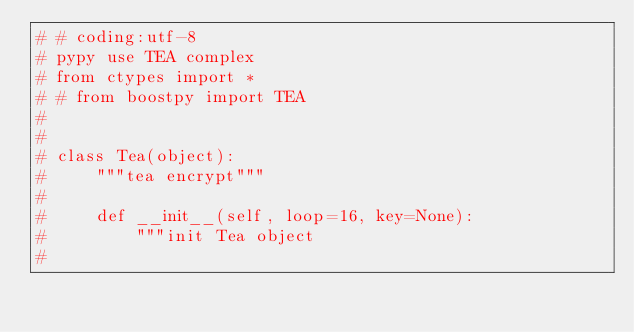<code> <loc_0><loc_0><loc_500><loc_500><_Python_># # coding:utf-8
# pypy use TEA complex
# from ctypes import *
# # from boostpy import TEA
#
#
# class Tea(object):
#     """tea encrypt"""
#
#     def __init__(self, loop=16, key=None):
#         """init Tea object
#</code> 